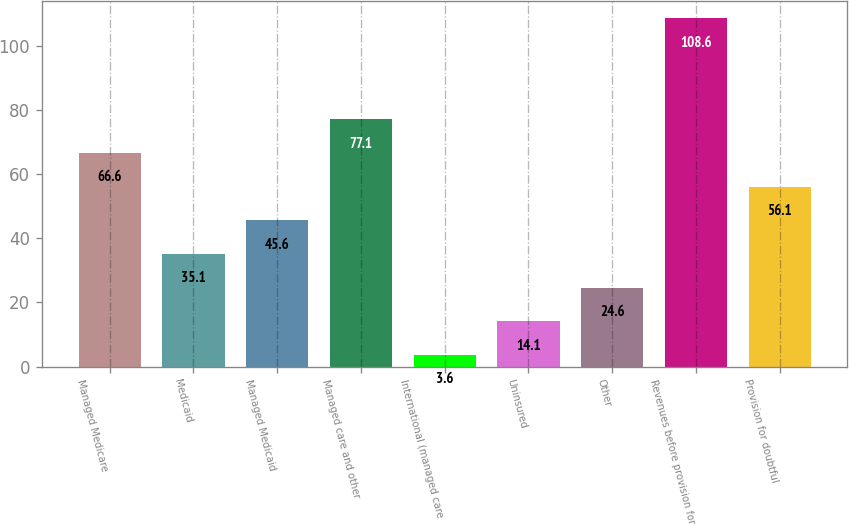Convert chart to OTSL. <chart><loc_0><loc_0><loc_500><loc_500><bar_chart><fcel>Managed Medicare<fcel>Medicaid<fcel>Managed Medicaid<fcel>Managed care and other<fcel>International (managed care<fcel>Uninsured<fcel>Other<fcel>Revenues before provision for<fcel>Provision for doubtful<nl><fcel>66.6<fcel>35.1<fcel>45.6<fcel>77.1<fcel>3.6<fcel>14.1<fcel>24.6<fcel>108.6<fcel>56.1<nl></chart> 